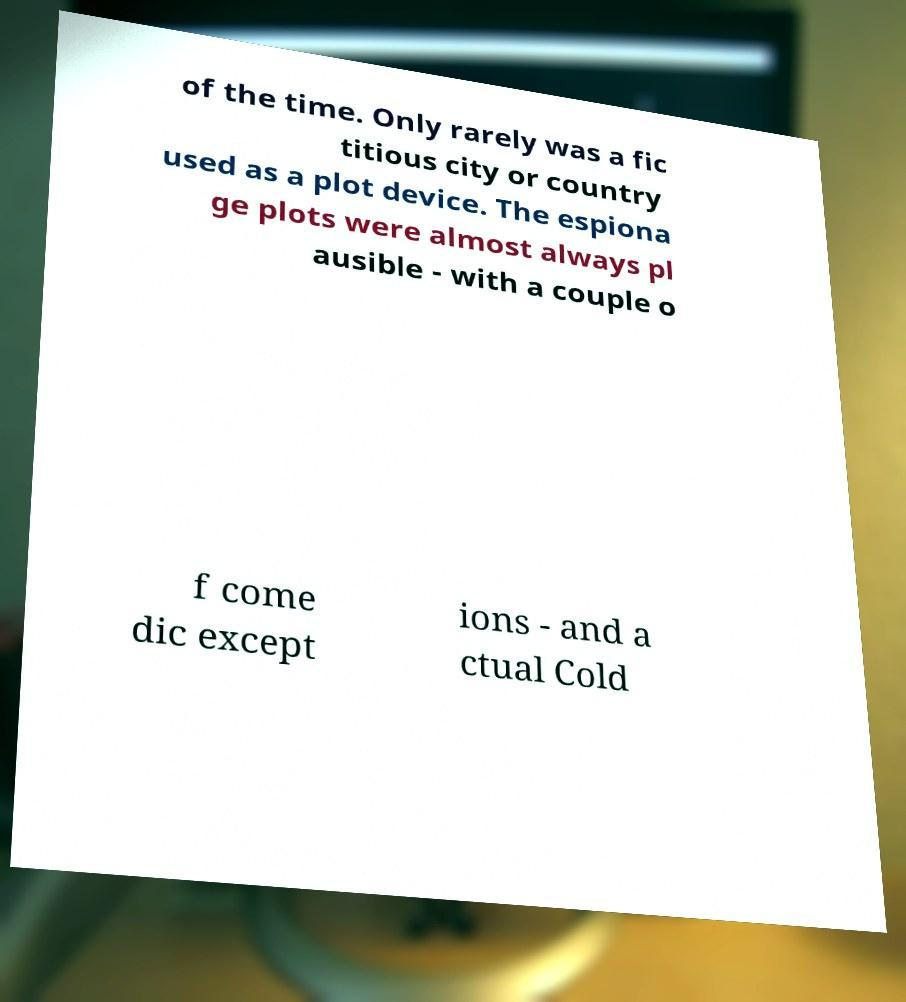Could you extract and type out the text from this image? of the time. Only rarely was a fic titious city or country used as a plot device. The espiona ge plots were almost always pl ausible - with a couple o f come dic except ions - and a ctual Cold 